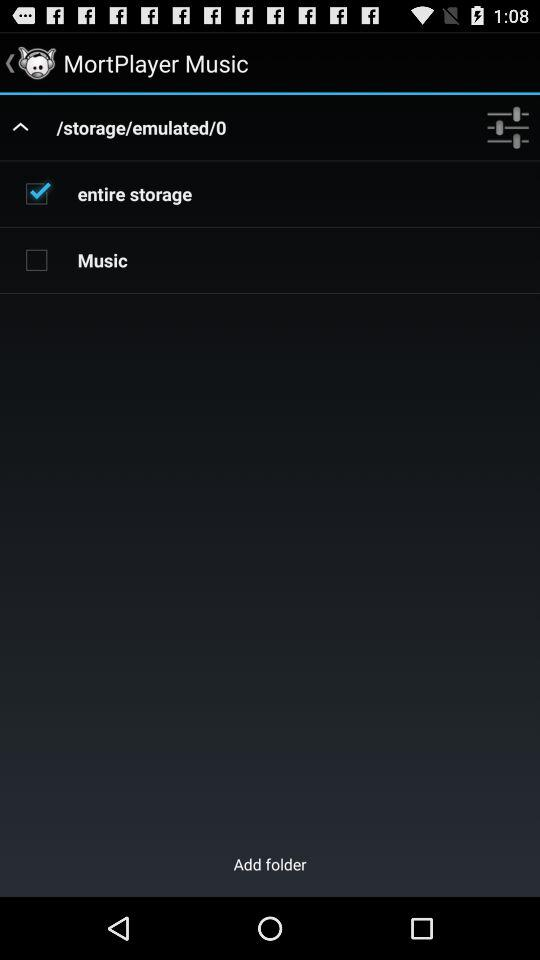What is the status of "Music"? The status is "off". 